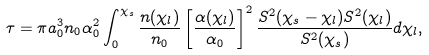Convert formula to latex. <formula><loc_0><loc_0><loc_500><loc_500>\tau = \pi a _ { 0 } ^ { 3 } n _ { 0 } \alpha _ { 0 } ^ { 2 } \int _ { 0 } ^ { \chi _ { s } } \frac { n ( \chi _ { l } ) } { n _ { 0 } } \left [ \frac { \alpha ( \chi _ { l } ) } { \alpha _ { 0 } } \right ] ^ { 2 } \frac { S ^ { 2 } ( \chi _ { s } - \chi _ { l } ) S ^ { 2 } ( \chi _ { l } ) } { S ^ { 2 } ( \chi _ { s } ) } d \chi _ { l } ,</formula> 